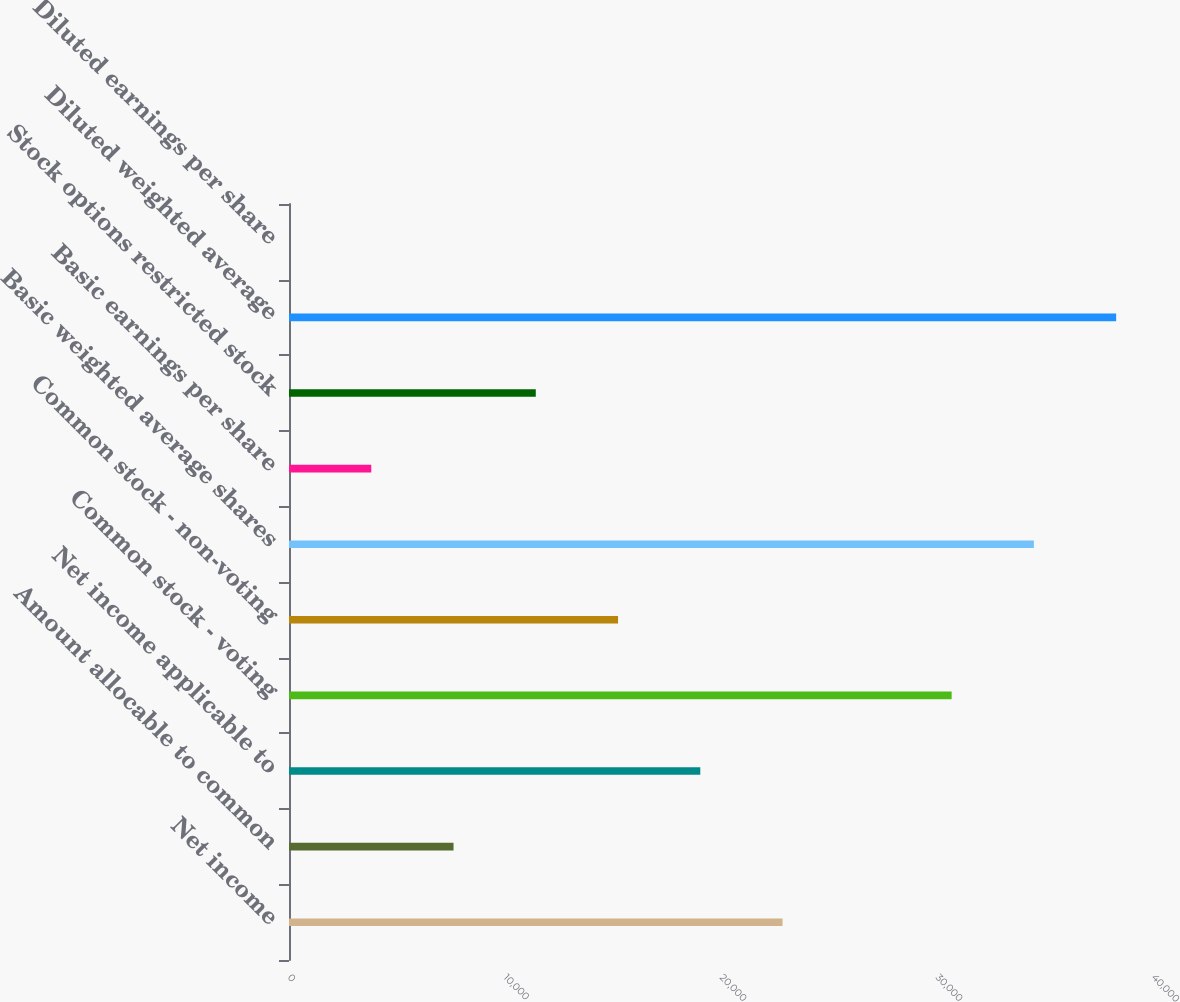<chart> <loc_0><loc_0><loc_500><loc_500><bar_chart><fcel>Net income<fcel>Amount allocable to common<fcel>Net income applicable to<fcel>Common stock - voting<fcel>Common stock - non-voting<fcel>Basic weighted average shares<fcel>Basic earnings per share<fcel>Stock options restricted stock<fcel>Diluted weighted average<fcel>Diluted earnings per share<nl><fcel>22849.4<fcel>7616.74<fcel>19041.2<fcel>30678<fcel>15233.1<fcel>34486.2<fcel>3808.58<fcel>11424.9<fcel>38294.3<fcel>0.42<nl></chart> 